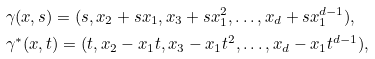<formula> <loc_0><loc_0><loc_500><loc_500>& \gamma ( x , s ) = ( s , x _ { 2 } + s x _ { 1 } , x _ { 3 } + s x _ { 1 } ^ { 2 } , \dots , x _ { d } + s x _ { 1 } ^ { d - 1 } ) , \\ & \gamma ^ { * } ( x , t ) = ( t , x _ { 2 } - x _ { 1 } t , x _ { 3 } - x _ { 1 } t ^ { 2 } , \dots , x _ { d } - x _ { 1 } t ^ { d - 1 } ) ,</formula> 